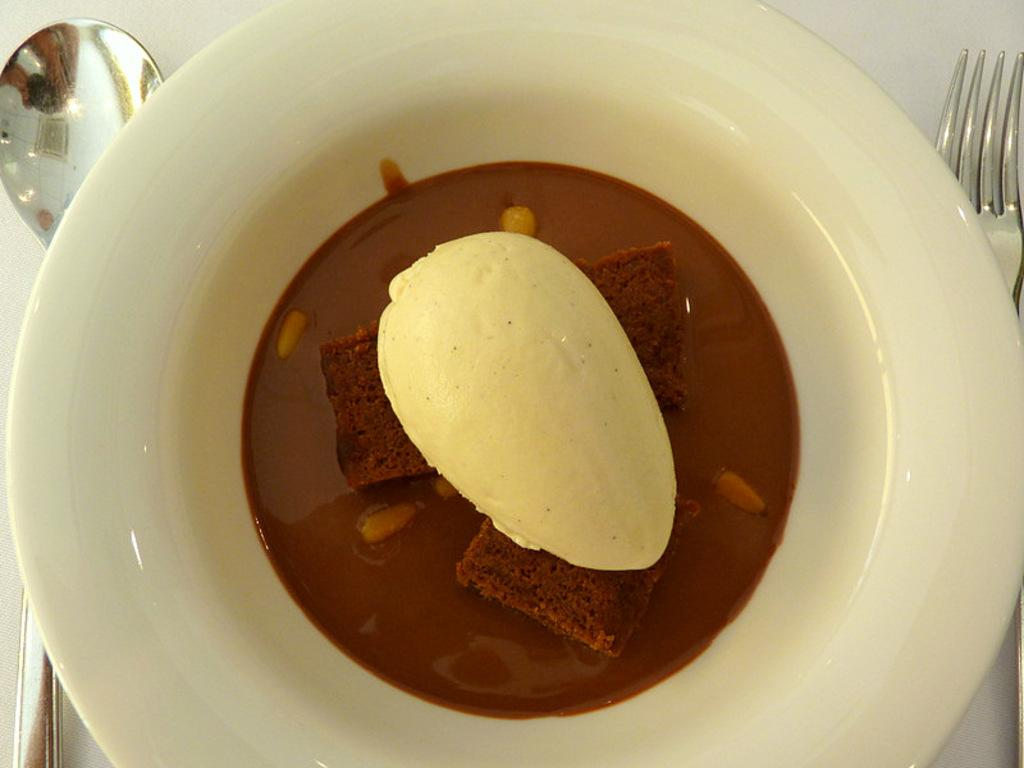What is in the bowl that is visible in the image? There are cake pieces in the bowl. What is on the cake pieces in the bowl? There is cream on the cake pieces. What utensils are present in the image? There is a spoon on the left side of the image and a fork on the right side of the image. What type of farm can be seen in the background of the image? There is no farm visible in the image; it only shows a bowl with cake pieces, cream, a spoon, and a fork. 